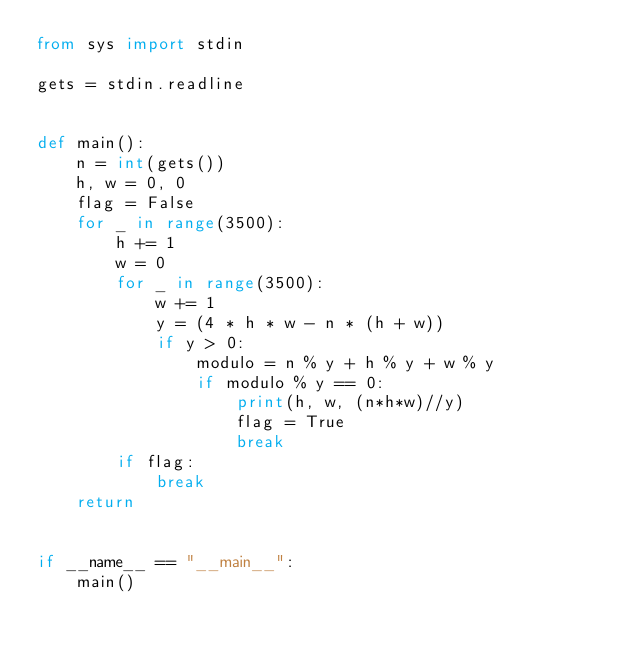<code> <loc_0><loc_0><loc_500><loc_500><_Python_>from sys import stdin

gets = stdin.readline


def main():
    n = int(gets())
    h, w = 0, 0
    flag = False
    for _ in range(3500):
        h += 1
        w = 0
        for _ in range(3500):
            w += 1
            y = (4 * h * w - n * (h + w))
            if y > 0:
                modulo = n % y + h % y + w % y
                if modulo % y == 0:
                    print(h, w, (n*h*w)//y)
                    flag = True
                    break
        if flag:
            break
    return


if __name__ == "__main__":
    main()
</code> 